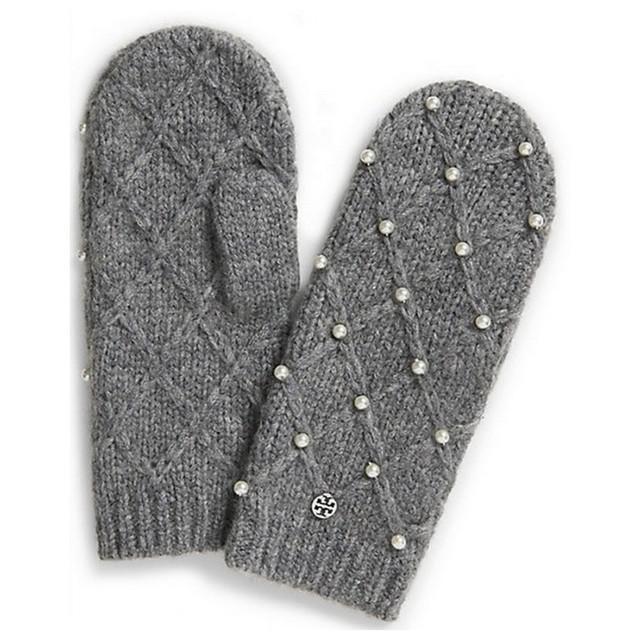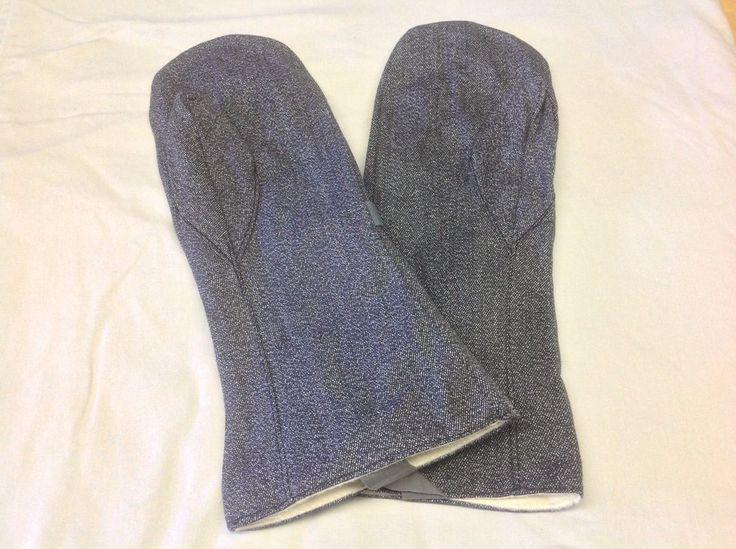The first image is the image on the left, the second image is the image on the right. Examine the images to the left and right. Is the description "All mittens shown have rounded tops without fingers, and the knitted mitten pair on the left is a solid color with a diamond pattern." accurate? Answer yes or no. Yes. 